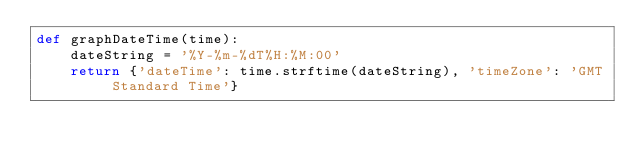<code> <loc_0><loc_0><loc_500><loc_500><_Python_>def graphDateTime(time):
    dateString = '%Y-%m-%dT%H:%M:00'
    return {'dateTime': time.strftime(dateString), 'timeZone': 'GMT Standard Time'}
</code> 